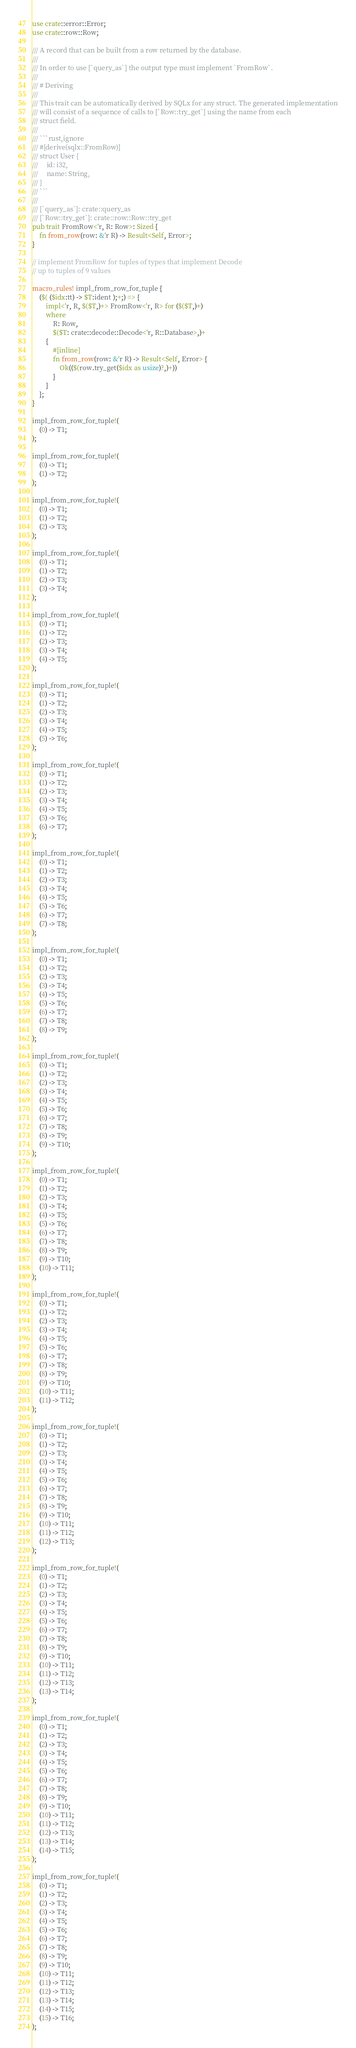Convert code to text. <code><loc_0><loc_0><loc_500><loc_500><_Rust_>use crate::error::Error;
use crate::row::Row;

/// A record that can be built from a row returned by the database.
///
/// In order to use [`query_as`] the output type must implement `FromRow`.
///
/// # Deriving
///
/// This trait can be automatically derived by SQLx for any struct. The generated implementation
/// will consist of a sequence of calls to [`Row::try_get`] using the name from each
/// struct field.
///
/// ```rust,ignore
/// #[derive(sqlx::FromRow)]
/// struct User {
///     id: i32,
///     name: String,
/// }
/// ```
///
/// [`query_as`]: crate::query_as
/// [`Row::try_get`]: crate::row::Row::try_get
pub trait FromRow<'r, R: Row>: Sized {
    fn from_row(row: &'r R) -> Result<Self, Error>;
}

// implement FromRow for tuples of types that implement Decode
// up to tuples of 9 values

macro_rules! impl_from_row_for_tuple {
    ($( ($idx:tt) -> $T:ident );+;) => {
        impl<'r, R, $($T,)+> FromRow<'r, R> for ($($T,)+)
        where
            R: Row,
            $($T: crate::decode::Decode<'r, R::Database>,)+
        {
            #[inline]
            fn from_row(row: &'r R) -> Result<Self, Error> {
                Ok(($(row.try_get($idx as usize)?,)+))
            }
        }
    };
}

impl_from_row_for_tuple!(
    (0) -> T1;
);

impl_from_row_for_tuple!(
    (0) -> T1;
    (1) -> T2;
);

impl_from_row_for_tuple!(
    (0) -> T1;
    (1) -> T2;
    (2) -> T3;
);

impl_from_row_for_tuple!(
    (0) -> T1;
    (1) -> T2;
    (2) -> T3;
    (3) -> T4;
);

impl_from_row_for_tuple!(
    (0) -> T1;
    (1) -> T2;
    (2) -> T3;
    (3) -> T4;
    (4) -> T5;
);

impl_from_row_for_tuple!(
    (0) -> T1;
    (1) -> T2;
    (2) -> T3;
    (3) -> T4;
    (4) -> T5;
    (5) -> T6;
);

impl_from_row_for_tuple!(
    (0) -> T1;
    (1) -> T2;
    (2) -> T3;
    (3) -> T4;
    (4) -> T5;
    (5) -> T6;
    (6) -> T7;
);

impl_from_row_for_tuple!(
    (0) -> T1;
    (1) -> T2;
    (2) -> T3;
    (3) -> T4;
    (4) -> T5;
    (5) -> T6;
    (6) -> T7;
    (7) -> T8;
);

impl_from_row_for_tuple!(
    (0) -> T1;
    (1) -> T2;
    (2) -> T3;
    (3) -> T4;
    (4) -> T5;
    (5) -> T6;
    (6) -> T7;
    (7) -> T8;
    (8) -> T9;
);

impl_from_row_for_tuple!(
    (0) -> T1;
    (1) -> T2;
    (2) -> T3;
    (3) -> T4;
    (4) -> T5;
    (5) -> T6;
    (6) -> T7;
    (7) -> T8;
    (8) -> T9;
    (9) -> T10;
);

impl_from_row_for_tuple!(
    (0) -> T1;
    (1) -> T2;
    (2) -> T3;
    (3) -> T4;
    (4) -> T5;
    (5) -> T6;
    (6) -> T7;
    (7) -> T8;
    (8) -> T9;
    (9) -> T10;
    (10) -> T11;
);

impl_from_row_for_tuple!(
    (0) -> T1;
    (1) -> T2;
    (2) -> T3;
    (3) -> T4;
    (4) -> T5;
    (5) -> T6;
    (6) -> T7;
    (7) -> T8;
    (8) -> T9;
    (9) -> T10;
    (10) -> T11;
    (11) -> T12;
);

impl_from_row_for_tuple!(
    (0) -> T1;
    (1) -> T2;
    (2) -> T3;
    (3) -> T4;
    (4) -> T5;
    (5) -> T6;
    (6) -> T7;
    (7) -> T8;
    (8) -> T9;
    (9) -> T10;
    (10) -> T11;
    (11) -> T12;
    (12) -> T13;
);

impl_from_row_for_tuple!(
    (0) -> T1;
    (1) -> T2;
    (2) -> T3;
    (3) -> T4;
    (4) -> T5;
    (5) -> T6;
    (6) -> T7;
    (7) -> T8;
    (8) -> T9;
    (9) -> T10;
    (10) -> T11;
    (11) -> T12;
    (12) -> T13;
    (13) -> T14;
);

impl_from_row_for_tuple!(
    (0) -> T1;
    (1) -> T2;
    (2) -> T3;
    (3) -> T4;
    (4) -> T5;
    (5) -> T6;
    (6) -> T7;
    (7) -> T8;
    (8) -> T9;
    (9) -> T10;
    (10) -> T11;
    (11) -> T12;
    (12) -> T13;
    (13) -> T14;
    (14) -> T15;
);

impl_from_row_for_tuple!(
    (0) -> T1;
    (1) -> T2;
    (2) -> T3;
    (3) -> T4;
    (4) -> T5;
    (5) -> T6;
    (6) -> T7;
    (7) -> T8;
    (8) -> T9;
    (9) -> T10;
    (10) -> T11;
    (11) -> T12;
    (12) -> T13;
    (13) -> T14;
    (14) -> T15;
    (15) -> T16;
);
</code> 